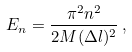<formula> <loc_0><loc_0><loc_500><loc_500>E _ { n } = \frac { \pi ^ { 2 } n ^ { 2 } } { 2 M ( \Delta l ) ^ { 2 } } \, ,</formula> 